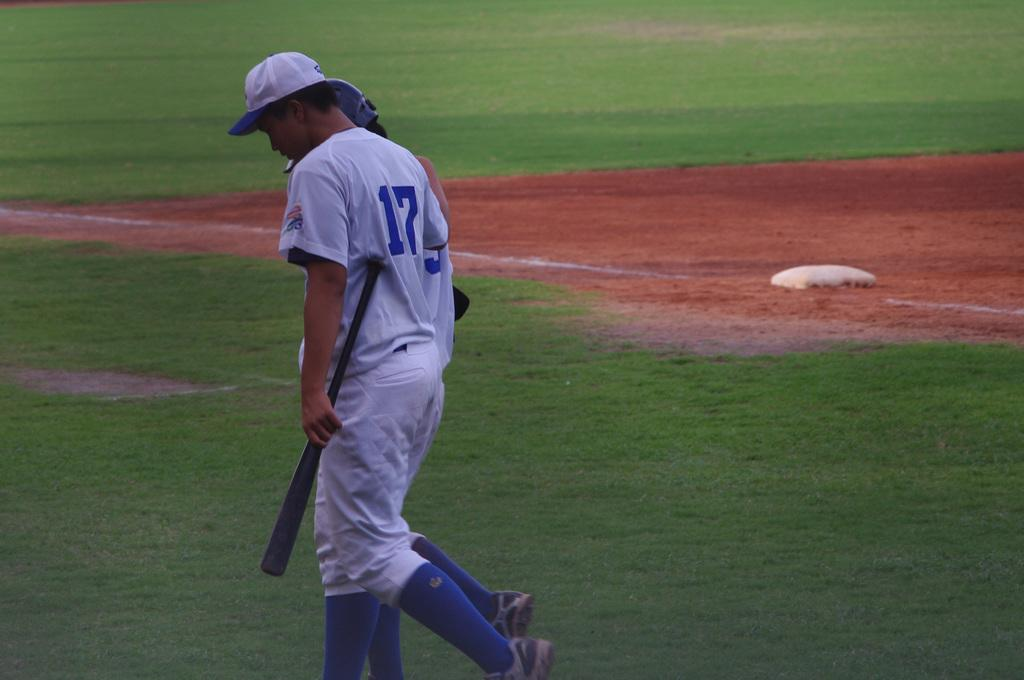Provide a one-sentence caption for the provided image. Number 17 baseball player holding bat dejectedly walking on playing field. 